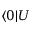<formula> <loc_0><loc_0><loc_500><loc_500>\langle 0 | U</formula> 